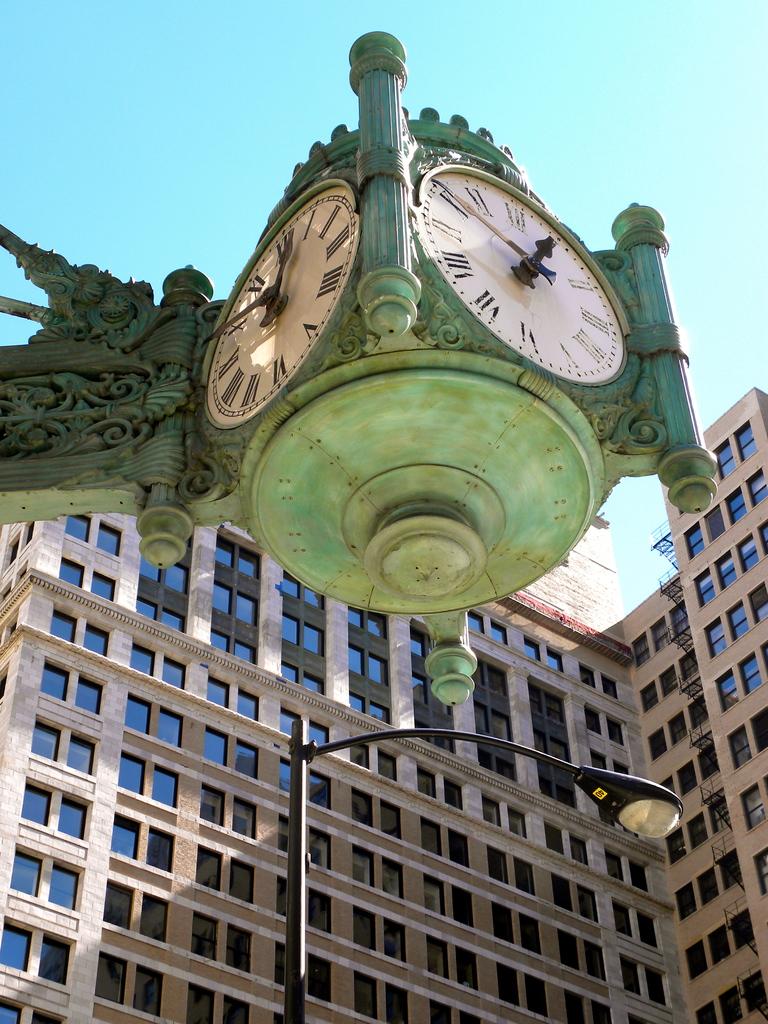What time does the clock say?
Give a very brief answer. 12:50. 